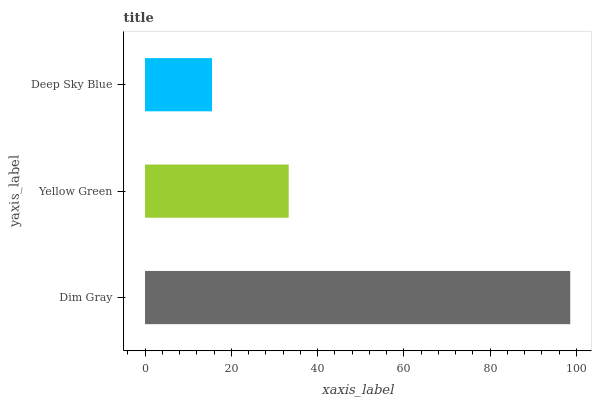Is Deep Sky Blue the minimum?
Answer yes or no. Yes. Is Dim Gray the maximum?
Answer yes or no. Yes. Is Yellow Green the minimum?
Answer yes or no. No. Is Yellow Green the maximum?
Answer yes or no. No. Is Dim Gray greater than Yellow Green?
Answer yes or no. Yes. Is Yellow Green less than Dim Gray?
Answer yes or no. Yes. Is Yellow Green greater than Dim Gray?
Answer yes or no. No. Is Dim Gray less than Yellow Green?
Answer yes or no. No. Is Yellow Green the high median?
Answer yes or no. Yes. Is Yellow Green the low median?
Answer yes or no. Yes. Is Dim Gray the high median?
Answer yes or no. No. Is Deep Sky Blue the low median?
Answer yes or no. No. 